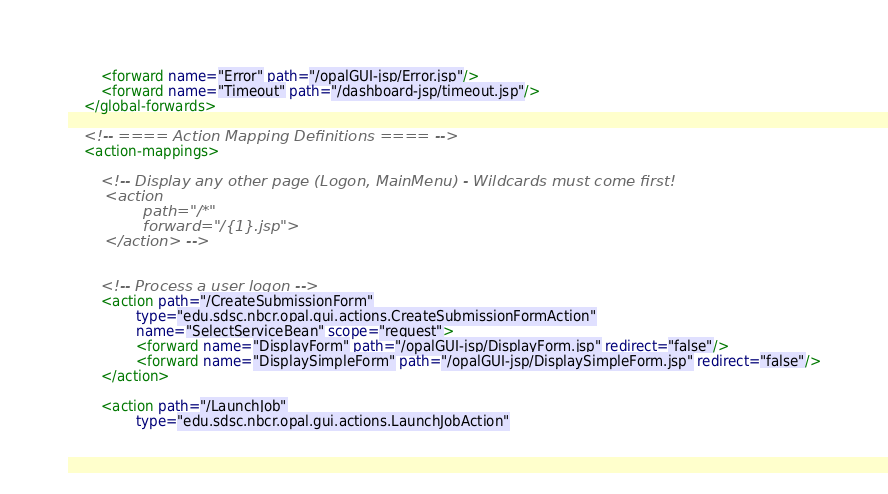<code> <loc_0><loc_0><loc_500><loc_500><_XML_>        <forward name="Error" path="/opalGUI-jsp/Error.jsp"/>
        <forward name="Timeout" path="/dashboard-jsp/timeout.jsp"/>
    </global-forwards>

    <!-- ==== Action Mapping Definitions ==== -->
    <action-mappings>

        <!-- Display any other page (Logon, MainMenu) - Wildcards must come first!
        <action
                path="/*"
                forward="/{1}.jsp">
        </action> -->


        <!-- Process a user logon -->
        <action path="/CreateSubmissionForm"
                type="edu.sdsc.nbcr.opal.gui.actions.CreateSubmissionFormAction"
                name="SelectServiceBean" scope="request">
                <forward name="DisplayForm" path="/opalGUI-jsp/DisplayForm.jsp" redirect="false"/>
                <forward name="DisplaySimpleForm" path="/opalGUI-jsp/DisplaySimpleForm.jsp" redirect="false"/>
        </action>

        <action path="/LaunchJob"
                type="edu.sdsc.nbcr.opal.gui.actions.LaunchJobAction"</code> 